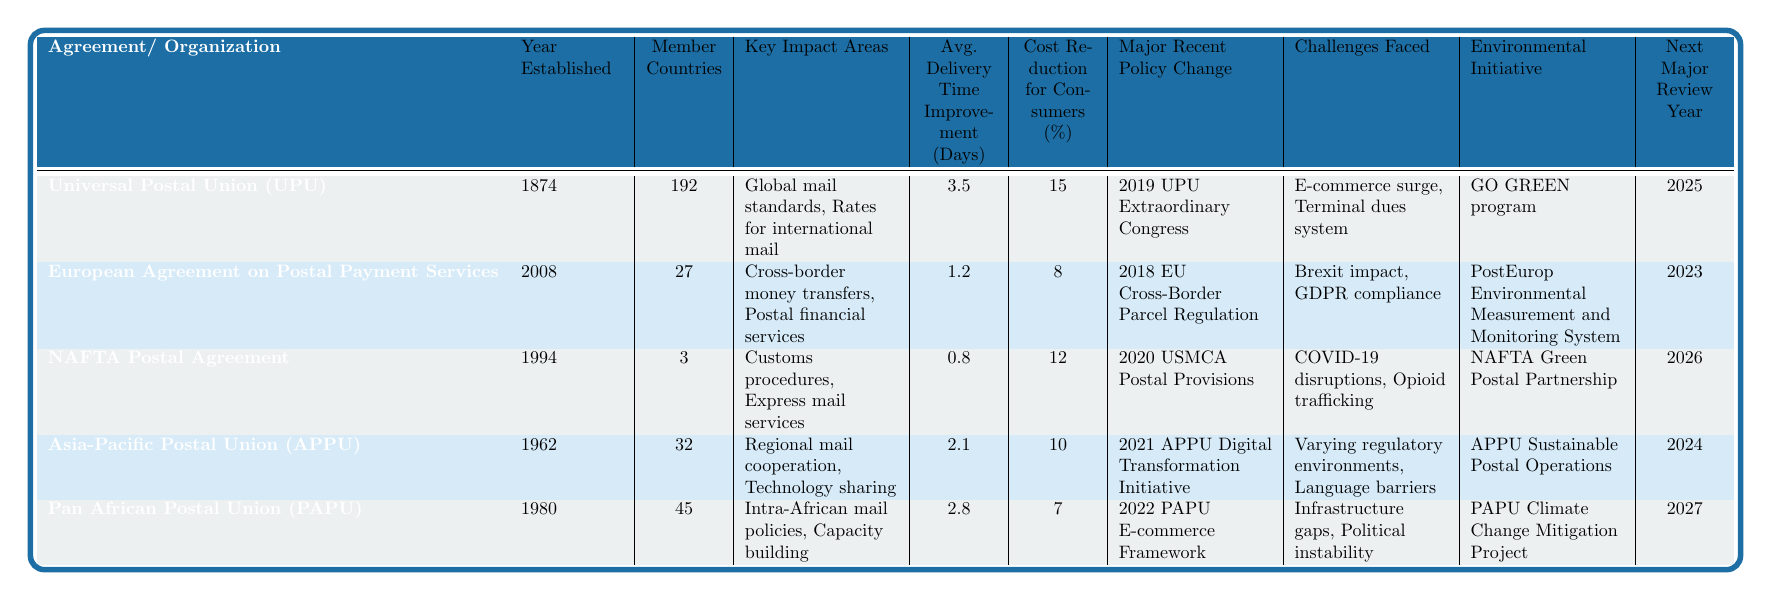What year was the Universal Postal Union established? The table indicates that the Universal Postal Union (UPU) was established in the year 1874.
Answer: 1874 How many member countries are part of the Asia-Pacific Postal Union? According to the table, the Asia-Pacific Postal Union (APPU) has 32 member countries.
Answer: 32 What is the average delivery time improvement for the Pan African Postal Union? The table shows that the average delivery time improvement for the Pan African Postal Union (PAPU) is 2.8 days.
Answer: 2.8 days Which postal agreement has the highest cost reduction for consumers? By comparing the cost reduction percentages in the table, the Universal Postal Union (UPU) has the highest at 15%.
Answer: 15% What is the next major review year for the European Agreement on Postal Payment Services? The table lists the next major review year for the European Agreement on Postal Payment Services as 2023.
Answer: 2023 Is there a postal agreement that is focused on environmental initiatives? Yes, all agreements listed have corresponding environmental initiatives mentioned in the table.
Answer: Yes What is the average delivery time improvement across all listed postal agreements? To find the average delivery time improvement, sum the values (3.5 + 1.2 + 0.8 + 2.1 + 2.8) = 10.4. Then divide by 5, resulting in an average of 10.4 / 5 = 2.08 days.
Answer: 2.08 days Which two agreements are impacted by e-commerce challenges? The table indicates that both the Universal Postal Union (UPU) and the Pan African Postal Union (PAPU) face e-commerce challenges.
Answer: UPU and PAPU How many member countries are part of the NAFTA Postal Agreement, and how does it compare to the Asia-Pacific Postal Union? The NAFTA Postal Agreement has 3 member countries, while the Asia-Pacific Postal Union has 32. This indicates that the APPU has significantly more member countries than NAFTA.
Answer: NAFTA: 3, APPU: 32 What major recent policy change occurred for the Pan African Postal Union? The table states that the major recent policy change for the Pan African Postal Union is the 2022 PAPU E-commerce Framework.
Answer: 2022 PAPU E-commerce Framework Which postal agreement established in 2008 is influenced by GDPR compliance? The European Agreement on Postal Payment Services established in 2008 is influenced by GDPR compliance, according to the table.
Answer: European Agreement on Postal Payment Services 